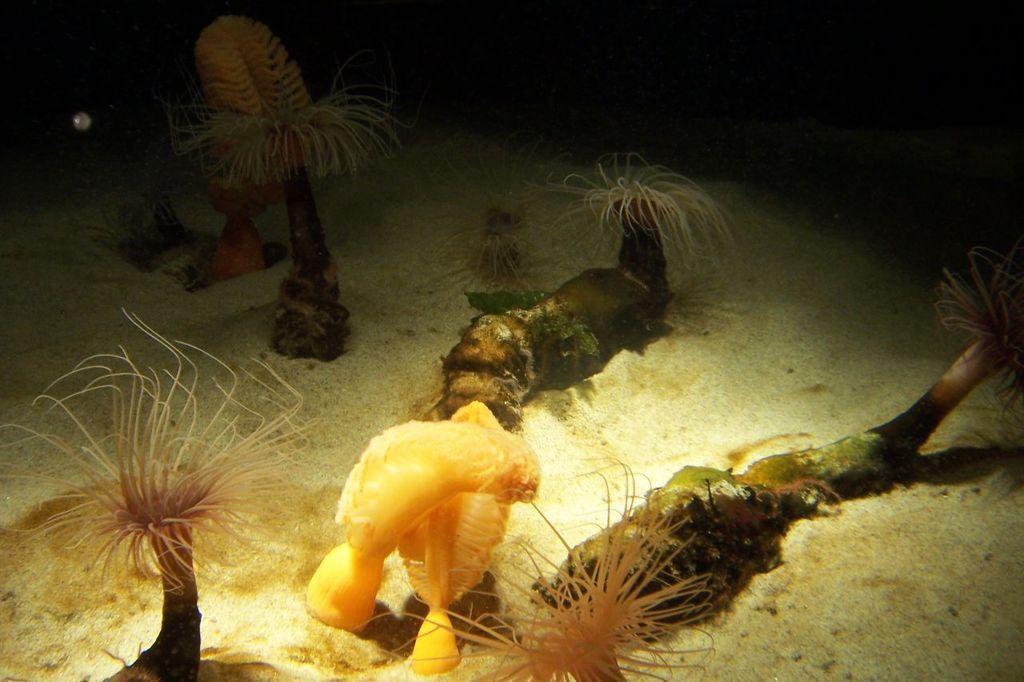Can you describe this image briefly? In this picture we can see plants and some objects on the ground and in the background it is dark. 